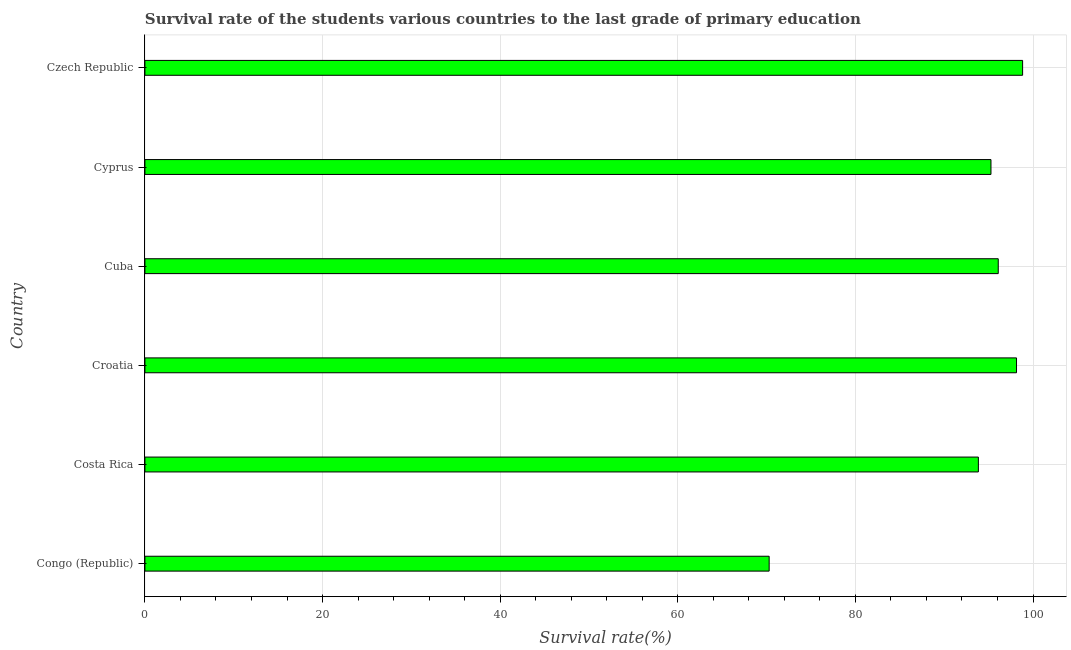Does the graph contain any zero values?
Provide a short and direct response. No. Does the graph contain grids?
Ensure brevity in your answer.  Yes. What is the title of the graph?
Make the answer very short. Survival rate of the students various countries to the last grade of primary education. What is the label or title of the X-axis?
Offer a terse response. Survival rate(%). What is the survival rate in primary education in Croatia?
Make the answer very short. 98.14. Across all countries, what is the maximum survival rate in primary education?
Ensure brevity in your answer.  98.83. Across all countries, what is the minimum survival rate in primary education?
Provide a succinct answer. 70.29. In which country was the survival rate in primary education maximum?
Keep it short and to the point. Czech Republic. In which country was the survival rate in primary education minimum?
Your response must be concise. Congo (Republic). What is the sum of the survival rate in primary education?
Offer a terse response. 552.47. What is the difference between the survival rate in primary education in Croatia and Cyprus?
Ensure brevity in your answer.  2.88. What is the average survival rate in primary education per country?
Your response must be concise. 92.08. What is the median survival rate in primary education?
Provide a succinct answer. 95.68. In how many countries, is the survival rate in primary education greater than 56 %?
Your answer should be compact. 6. What is the difference between the highest and the second highest survival rate in primary education?
Keep it short and to the point. 0.69. Is the sum of the survival rate in primary education in Cuba and Cyprus greater than the maximum survival rate in primary education across all countries?
Provide a succinct answer. Yes. What is the difference between the highest and the lowest survival rate in primary education?
Offer a very short reply. 28.54. In how many countries, is the survival rate in primary education greater than the average survival rate in primary education taken over all countries?
Provide a short and direct response. 5. How many bars are there?
Make the answer very short. 6. How many countries are there in the graph?
Give a very brief answer. 6. What is the Survival rate(%) in Congo (Republic)?
Provide a succinct answer. 70.29. What is the Survival rate(%) of Costa Rica?
Offer a terse response. 93.85. What is the Survival rate(%) in Croatia?
Provide a short and direct response. 98.14. What is the Survival rate(%) of Cuba?
Your response must be concise. 96.09. What is the Survival rate(%) of Cyprus?
Give a very brief answer. 95.27. What is the Survival rate(%) of Czech Republic?
Provide a succinct answer. 98.83. What is the difference between the Survival rate(%) in Congo (Republic) and Costa Rica?
Your answer should be compact. -23.56. What is the difference between the Survival rate(%) in Congo (Republic) and Croatia?
Your answer should be compact. -27.85. What is the difference between the Survival rate(%) in Congo (Republic) and Cuba?
Provide a short and direct response. -25.8. What is the difference between the Survival rate(%) in Congo (Republic) and Cyprus?
Your response must be concise. -24.98. What is the difference between the Survival rate(%) in Congo (Republic) and Czech Republic?
Make the answer very short. -28.54. What is the difference between the Survival rate(%) in Costa Rica and Croatia?
Make the answer very short. -4.29. What is the difference between the Survival rate(%) in Costa Rica and Cuba?
Ensure brevity in your answer.  -2.24. What is the difference between the Survival rate(%) in Costa Rica and Cyprus?
Make the answer very short. -1.42. What is the difference between the Survival rate(%) in Costa Rica and Czech Republic?
Your answer should be compact. -4.98. What is the difference between the Survival rate(%) in Croatia and Cuba?
Your response must be concise. 2.06. What is the difference between the Survival rate(%) in Croatia and Cyprus?
Your response must be concise. 2.88. What is the difference between the Survival rate(%) in Croatia and Czech Republic?
Provide a succinct answer. -0.69. What is the difference between the Survival rate(%) in Cuba and Cyprus?
Ensure brevity in your answer.  0.82. What is the difference between the Survival rate(%) in Cuba and Czech Republic?
Offer a terse response. -2.74. What is the difference between the Survival rate(%) in Cyprus and Czech Republic?
Provide a short and direct response. -3.56. What is the ratio of the Survival rate(%) in Congo (Republic) to that in Costa Rica?
Provide a short and direct response. 0.75. What is the ratio of the Survival rate(%) in Congo (Republic) to that in Croatia?
Provide a succinct answer. 0.72. What is the ratio of the Survival rate(%) in Congo (Republic) to that in Cuba?
Offer a terse response. 0.73. What is the ratio of the Survival rate(%) in Congo (Republic) to that in Cyprus?
Your response must be concise. 0.74. What is the ratio of the Survival rate(%) in Congo (Republic) to that in Czech Republic?
Keep it short and to the point. 0.71. What is the ratio of the Survival rate(%) in Costa Rica to that in Croatia?
Offer a terse response. 0.96. What is the ratio of the Survival rate(%) in Costa Rica to that in Cyprus?
Make the answer very short. 0.98. What is the ratio of the Survival rate(%) in Costa Rica to that in Czech Republic?
Keep it short and to the point. 0.95. What is the ratio of the Survival rate(%) in Croatia to that in Cuba?
Keep it short and to the point. 1.02. What is the ratio of the Survival rate(%) in Croatia to that in Cyprus?
Give a very brief answer. 1.03. What is the ratio of the Survival rate(%) in Cuba to that in Czech Republic?
Provide a succinct answer. 0.97. What is the ratio of the Survival rate(%) in Cyprus to that in Czech Republic?
Your answer should be compact. 0.96. 